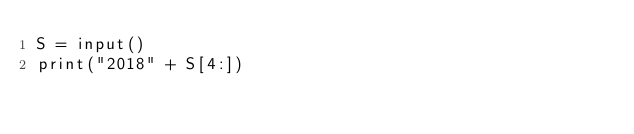<code> <loc_0><loc_0><loc_500><loc_500><_Python_>S = input()
print("2018" + S[4:])</code> 